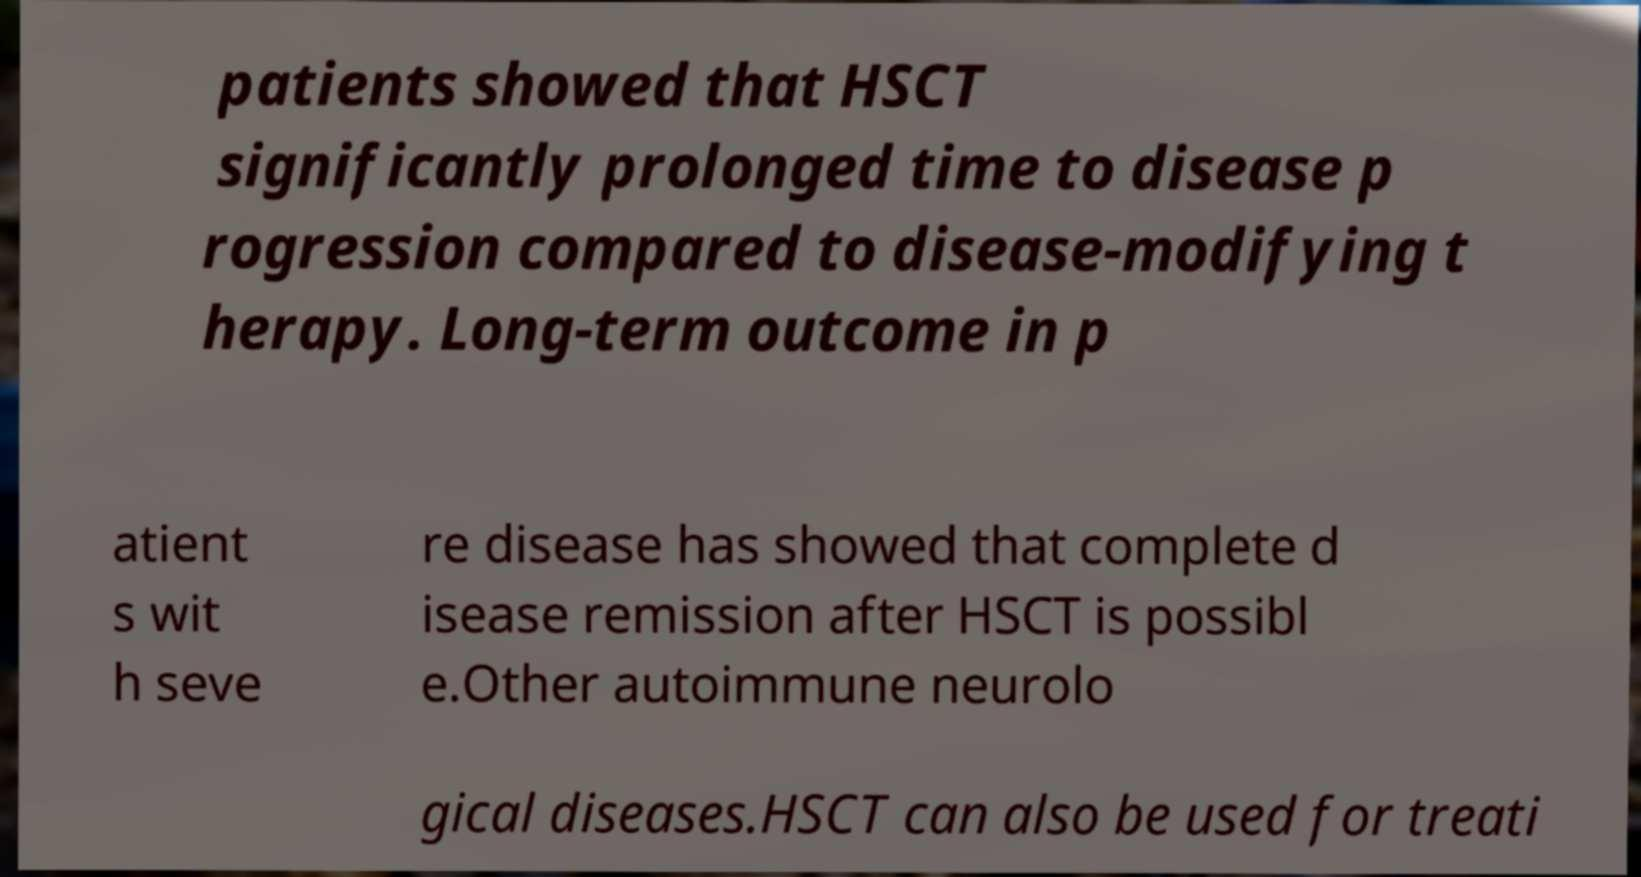For documentation purposes, I need the text within this image transcribed. Could you provide that? patients showed that HSCT significantly prolonged time to disease p rogression compared to disease-modifying t herapy. Long-term outcome in p atient s wit h seve re disease has showed that complete d isease remission after HSCT is possibl e.Other autoimmune neurolo gical diseases.HSCT can also be used for treati 